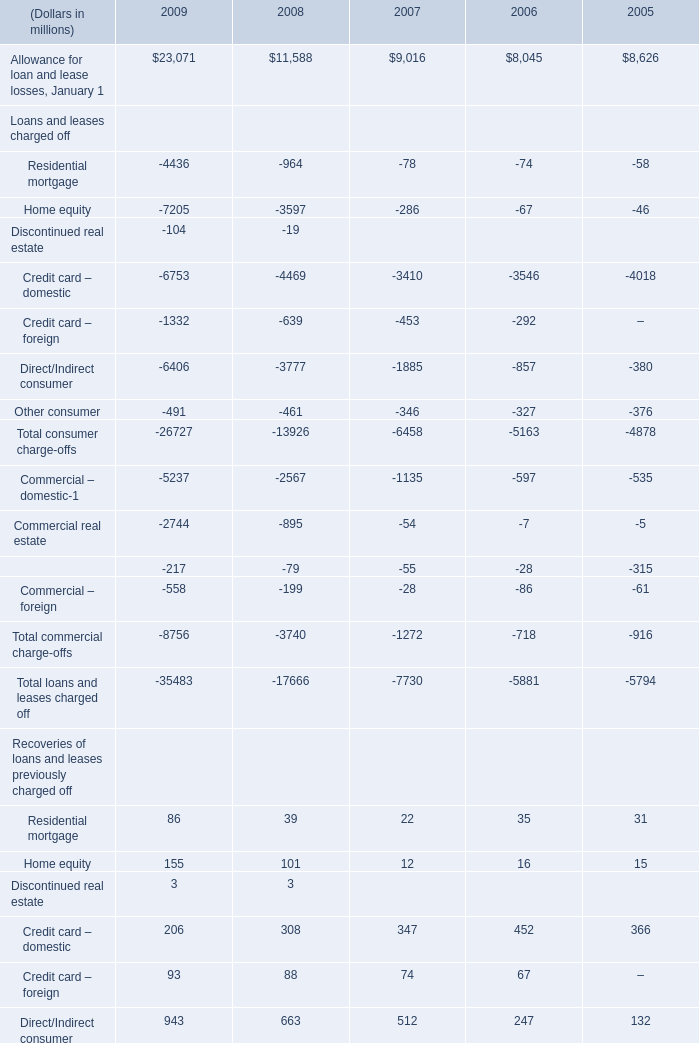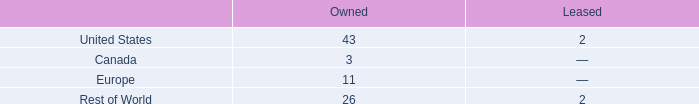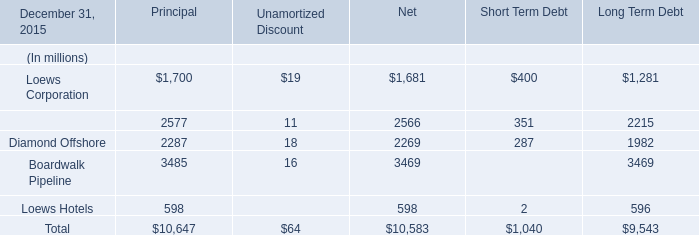as of december 31 , 2016 , what percentage of manufacturing and processing facilities are owned? 
Computations: (83 / 87)
Answer: 0.95402. 